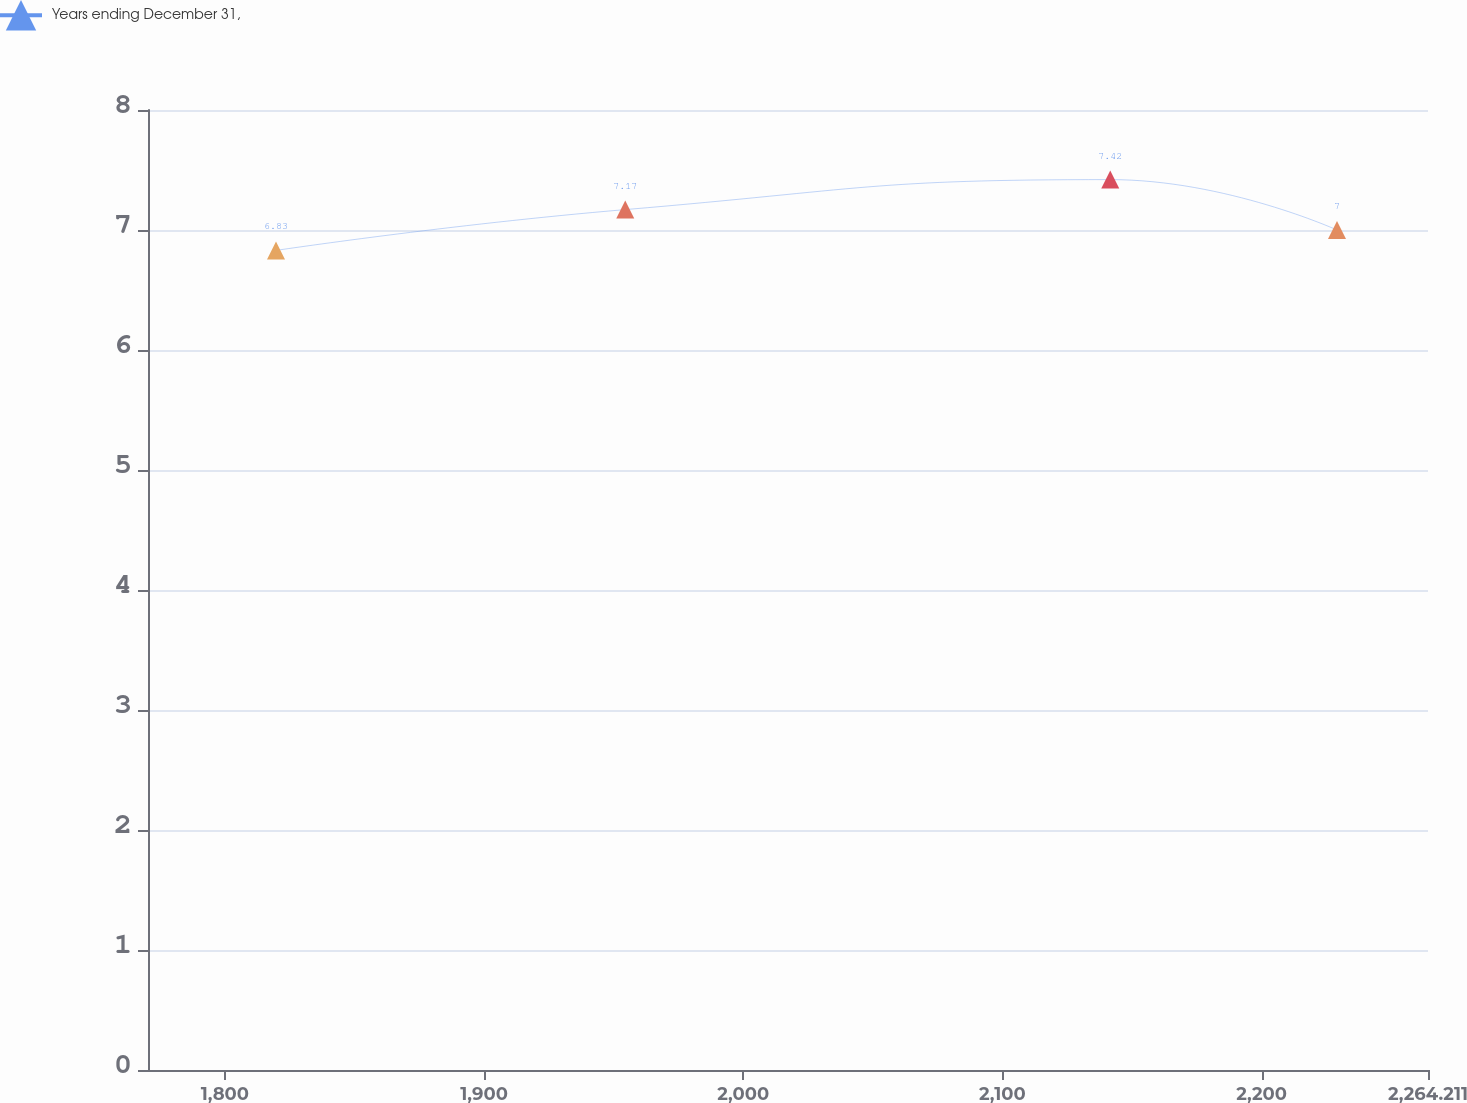<chart> <loc_0><loc_0><loc_500><loc_500><line_chart><ecel><fcel>Years ending December 31,<nl><fcel>1819.71<fcel>6.83<nl><fcel>1954.48<fcel>7.17<nl><fcel>2141.6<fcel>7.42<nl><fcel>2229.11<fcel>7<nl><fcel>2313.6<fcel>5.77<nl></chart> 